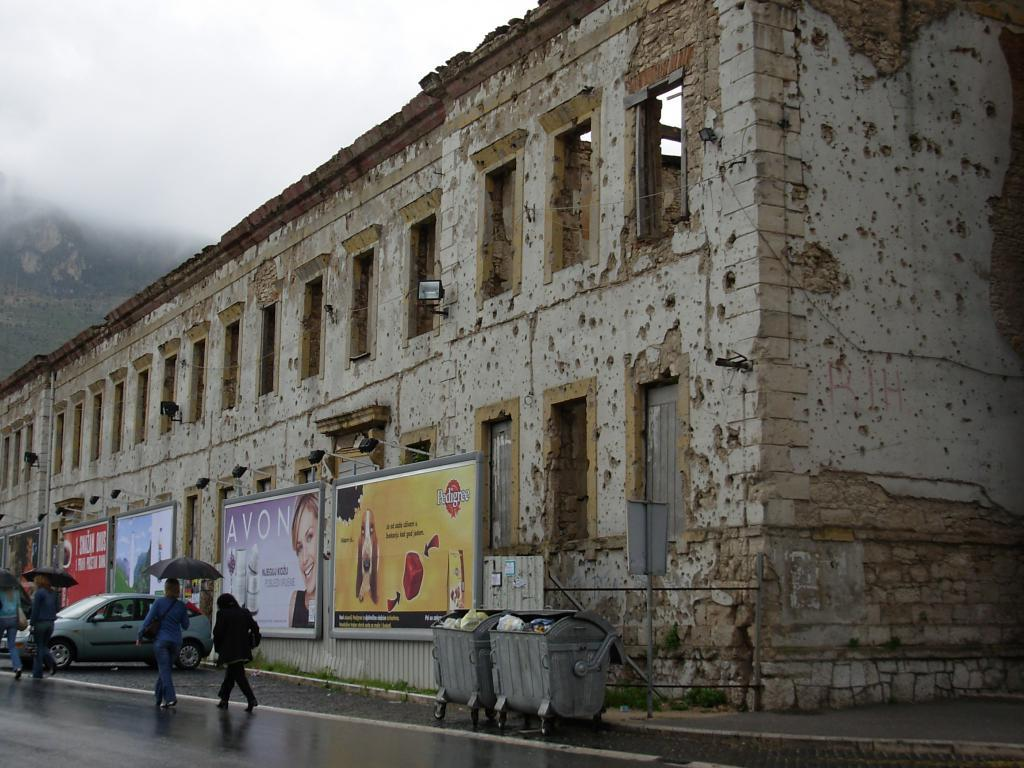<image>
Write a terse but informative summary of the picture. A damaged building with signs for Avon and Pedigree on the side. 